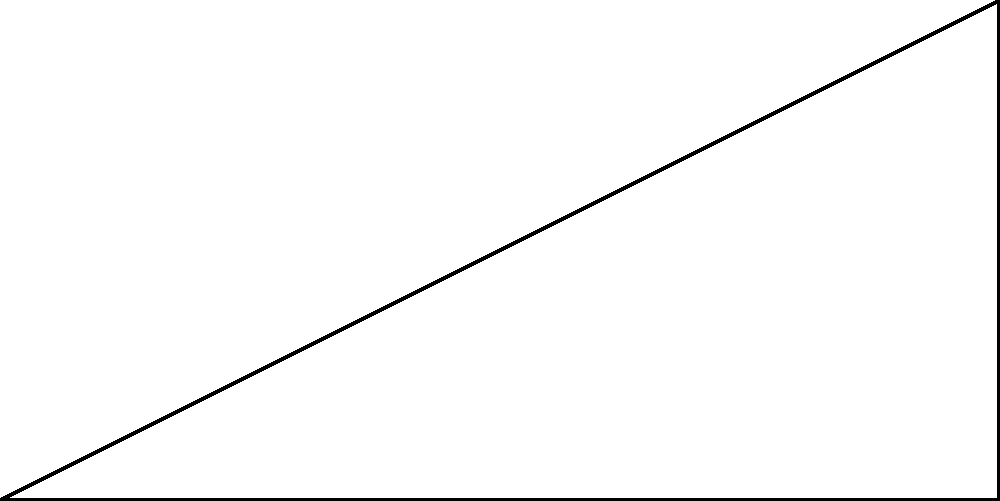In a long jump competition, an athlete wants to maximize their jump distance. Given that the initial velocity $v_0$ of the jump is 10 m/s and the maximum height $h$ reached is 1.25 m, what is the optimal angle $\theta$ of trajectory for the longest possible jump? Round your answer to the nearest degree. To solve this problem, we'll use the principles of projectile motion and trigonometry:

1) In projectile motion, the optimal angle for maximum distance is 45°. However, this is only true when the launch and landing heights are the same.

2) For a long jump, the landing height is the same as the launch height, but we need to consider the maximum height reached.

3) The relationship between the angle $\theta$, initial velocity $v_0$, and maximum height $h$ is:

   $$h = \frac{v_0^2 \sin^2 \theta}{2g}$$

   where $g$ is the acceleration due to gravity (9.8 m/s²).

4) Rearranging this equation:

   $$\sin^2 \theta = \frac{2gh}{v_0^2}$$

5) Substituting the given values:

   $$\sin^2 \theta = \frac{2 * 9.8 * 1.25}{10^2} = 0.245$$

6) Taking the square root of both sides:

   $$\sin \theta = \sqrt{0.245} = 0.495$$

7) To find $\theta$, we take the inverse sine (arcsin):

   $$\theta = \arcsin(0.495) = 29.7°$$

8) Rounding to the nearest degree:

   $$\theta \approx 30°$$

This angle is less than 45° because we're accounting for the maximum height reached during the jump, which affects the optimal trajectory for maximum distance.
Answer: 30° 